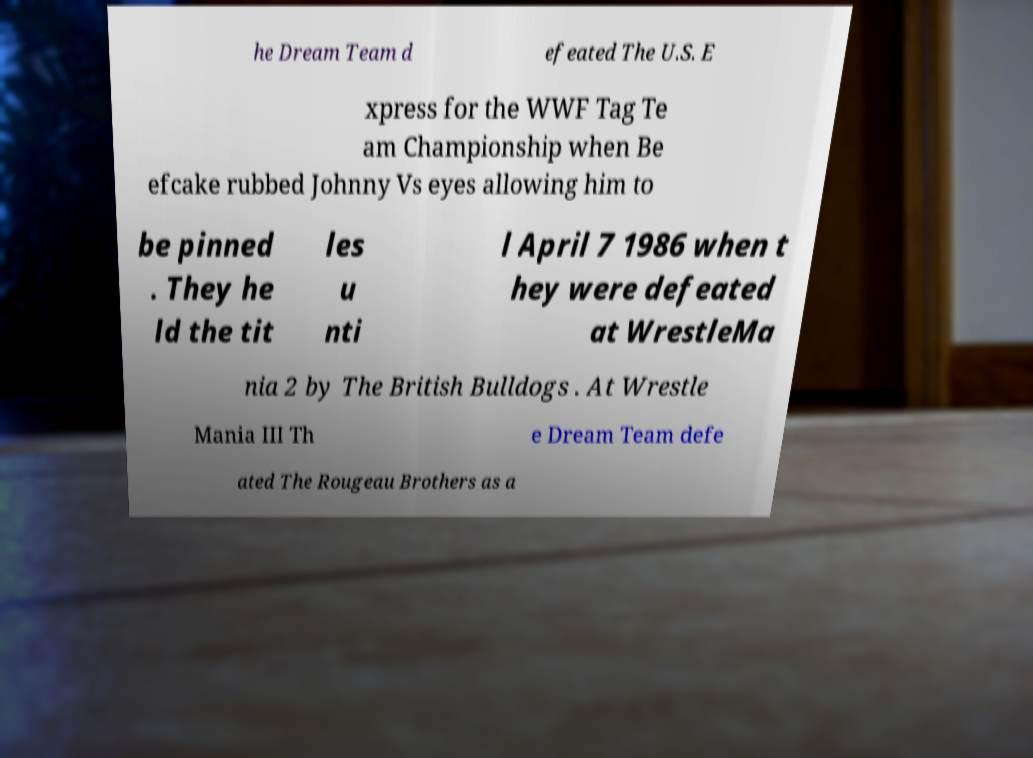Can you read and provide the text displayed in the image?This photo seems to have some interesting text. Can you extract and type it out for me? he Dream Team d efeated The U.S. E xpress for the WWF Tag Te am Championship when Be efcake rubbed Johnny Vs eyes allowing him to be pinned . They he ld the tit les u nti l April 7 1986 when t hey were defeated at WrestleMa nia 2 by The British Bulldogs . At Wrestle Mania III Th e Dream Team defe ated The Rougeau Brothers as a 